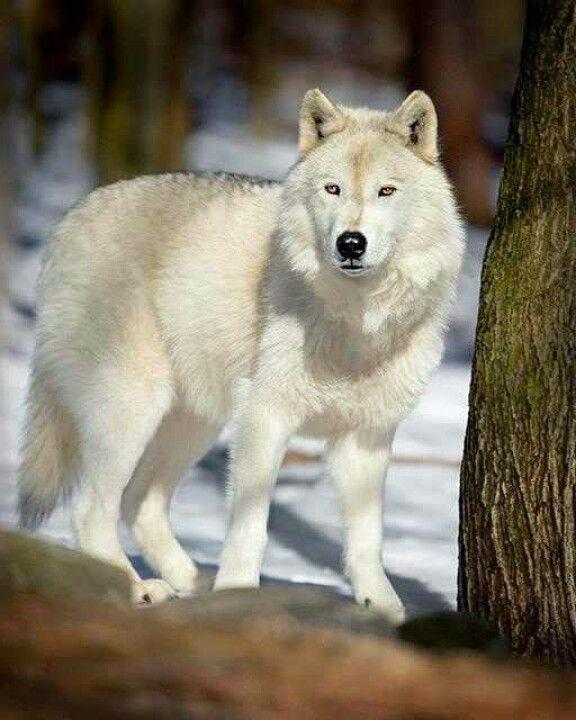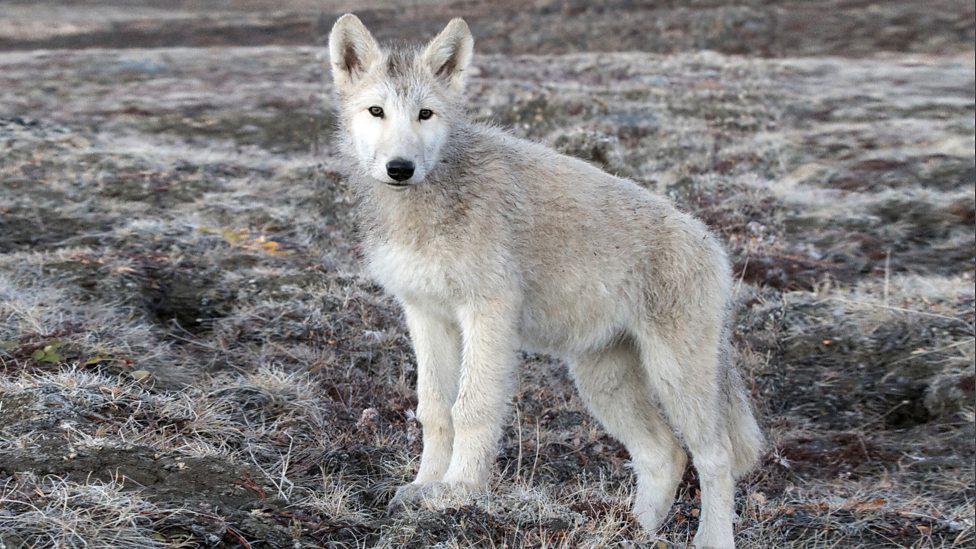The first image is the image on the left, the second image is the image on the right. Examine the images to the left and right. Is the description "The right image features one wolf reclining with its body turned leftward and its gaze slightly rightward, and the left image contains at least three wolves." accurate? Answer yes or no. No. The first image is the image on the left, the second image is the image on the right. Evaluate the accuracy of this statement regarding the images: "The left image contains at least two wolves.". Is it true? Answer yes or no. No. 